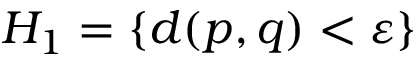Convert formula to latex. <formula><loc_0><loc_0><loc_500><loc_500>H _ { 1 } = \{ d ( p , q ) < \varepsilon \}</formula> 